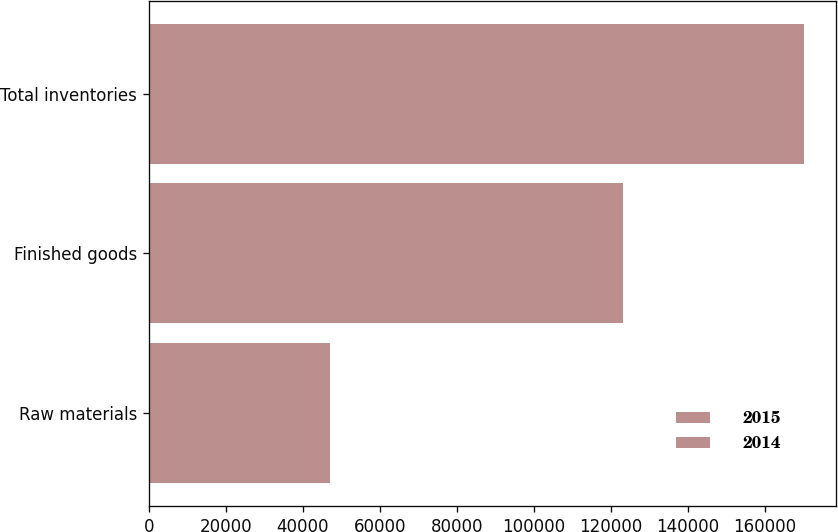<chart> <loc_0><loc_0><loc_500><loc_500><stacked_bar_chart><ecel><fcel>Raw materials<fcel>Finished goods<fcel>Total inventories<nl><fcel>2015<fcel>29831<fcel>62298<fcel>92129<nl><fcel>2014<fcel>17094<fcel>60912<fcel>78006<nl></chart> 